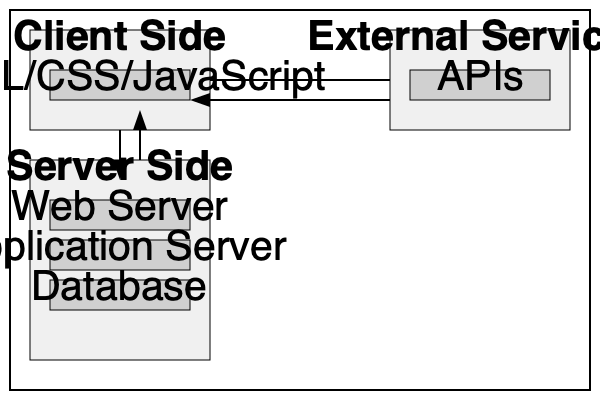In the given web application architecture diagram, which component acts as an intermediary between the client-side and the database, handling business logic and data processing? To answer this question, let's analyze the components of the web application architecture diagram:

1. The diagram is divided into three main sections: Client Side, Server Side, and External Services.

2. On the Client Side, we see HTML/CSS/JavaScript, which represents the user interface and client-side logic.

3. On the Server Side, we have three components:
   a. Web Server
   b. Application Server
   c. Database

4. The External Services section shows APIs, which are separate from the main application structure.

5. The data flow arrows indicate communication between the Client Side and the Server Side, as well as between the Client Side and External Services.

6. In a typical web application architecture, the Application Server sits between the Web Server and the Database. It's responsible for:
   - Executing the core business logic of the application
   - Processing data received from the client
   - Interacting with the database to fetch or store data
   - Preparing responses to be sent back to the client

7. The Web Server primarily handles HTTP requests and serves static content, while the Database is responsible for data storage and retrieval.

Therefore, the component that acts as an intermediary between the client-side and the database, handling business logic and data processing, is the Application Server.
Answer: Application Server 